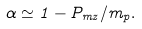Convert formula to latex. <formula><loc_0><loc_0><loc_500><loc_500>\alpha \simeq 1 - P _ { m z } / m _ { p } .</formula> 